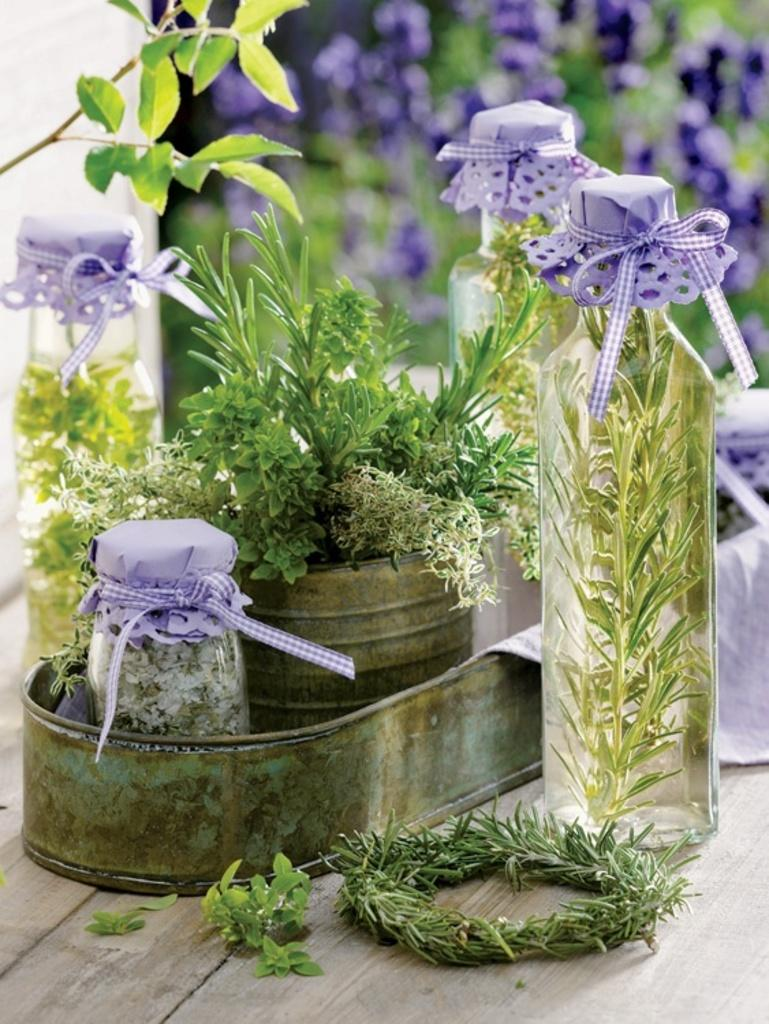What type of container is visible in the image? There is a flower pot in the image. What other containers can be seen in the image? There is a jar and bottles visible in the image. What can be found on the tray in the image? The tray is placed on a table, and there are leaves on it. What is present in the background of the image? There are flowers in the background of the image. What type of sidewalk can be seen in the image? There is no sidewalk present in the image. What territory is being claimed by the flowers in the image? The image does not depict any territorial claims; it simply shows flowers in the background. 